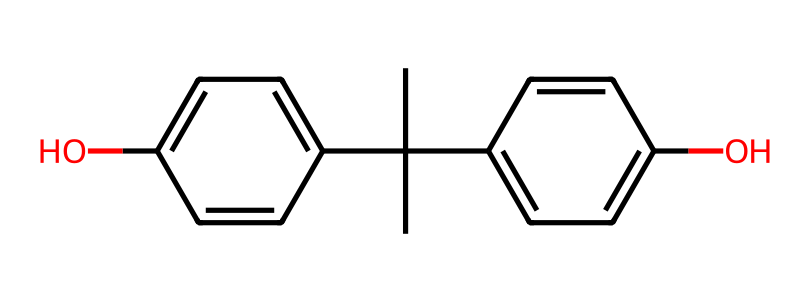What is the molecular formula of bisphenol A? The structure contains two phenol groups which can be identified from the 'c' (carbon in aromatic ring) notations in the SMILES. Counting all the carbon (C), hydrogen (H), and oxygen (O) atoms present provides the molecular formula. There are 15 carbon atoms, 16 hydrogen atoms, and 2 oxygen atoms.
Answer: C15H16O2 How many hydroxyl (–OH) groups are present in bisphenol A? The visual representation suggests that there are two –OH groups directly bonded to the benzene rings in the structure, indicated by the ‘O’ in the SMILES. So, by examining the structure, we can ascertain that there are two hydroxyl groups.
Answer: 2 What type of functional groups does bisphenol A have? The presence of the –OH group indicates that this chemical is classified as a phenolic compound. Additionally, the molecular structure shows that it consists of aromatic rings which are characteristic of phenols. Therefore, the functional group is phenolic.
Answer: phenolic What is the number of aromatic rings in bisphenol A? Analyzing the molecular structure from the SMILES shows there are two aromatic rings derived from the ‘c’ notations and their connectivity. Each aromatic section corresponds to one benzene ring, confirming the presence of two.
Answer: 2 Explain why bisphenol A is considered controversial. Bisphenol A is controversial due to its endocrine-disrupting properties, which derive from its structure that allows it to mimic estrogen. This mimicry can lead to significant biological effects. The presence of two phenolic –OH groups contributes to this activity.
Answer: endocrine disruptor 